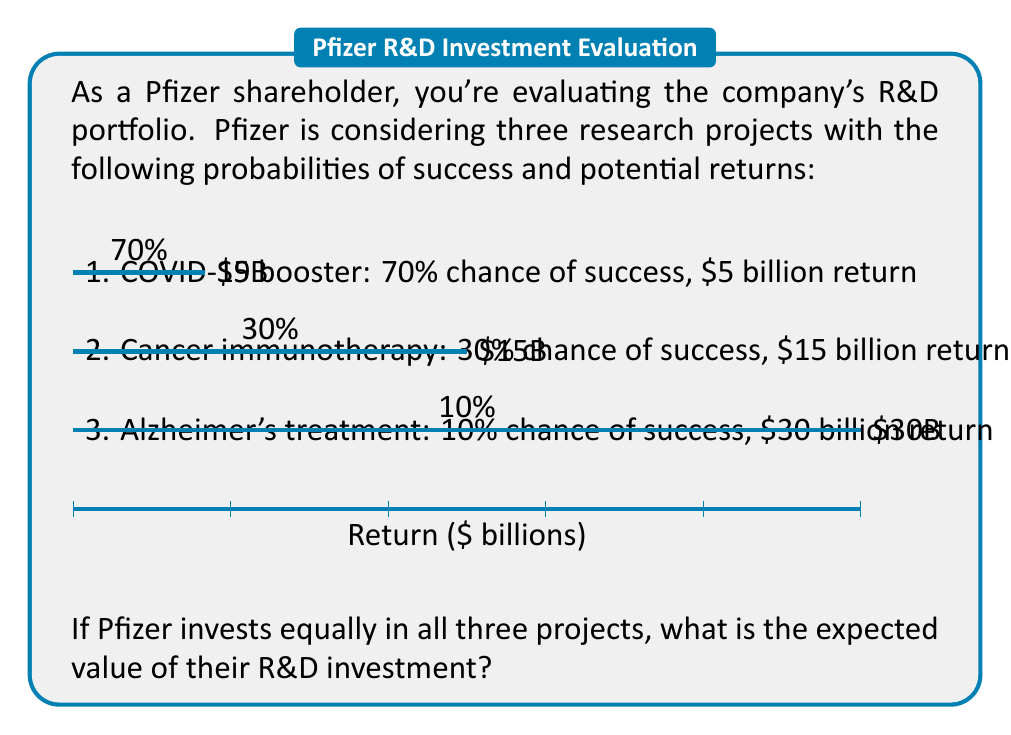Solve this math problem. To calculate the expected value of Pfizer's R&D investment, we need to:

1. Calculate the expected value of each project
2. Sum these values to get the total expected value

Let's go through each step:

1. Expected value for each project:

   a) COVID-19 booster:
      $E_1 = 0.70 \times \$5\text{ billion} = \$3.5\text{ billion}$

   b) Cancer immunotherapy:
      $E_2 = 0.30 \times \$15\text{ billion} = \$4.5\text{ billion}$

   c) Alzheimer's treatment:
      $E_3 = 0.10 \times \$30\text{ billion} = \$3\text{ billion}$

2. Total expected value:

   $E_{total} = E_1 + E_2 + E_3$
   $E_{total} = \$3.5\text{ billion} + \$4.5\text{ billion} + \$3\text{ billion}$
   $E_{total} = \$11\text{ billion}$

Therefore, the expected value of Pfizer's R&D investment across these three projects is $11 billion.
Answer: $11 billion 